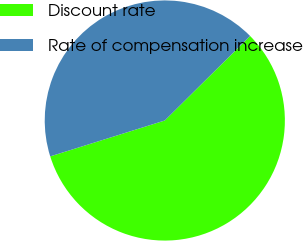Convert chart. <chart><loc_0><loc_0><loc_500><loc_500><pie_chart><fcel>Discount rate<fcel>Rate of compensation increase<nl><fcel>57.59%<fcel>42.41%<nl></chart> 